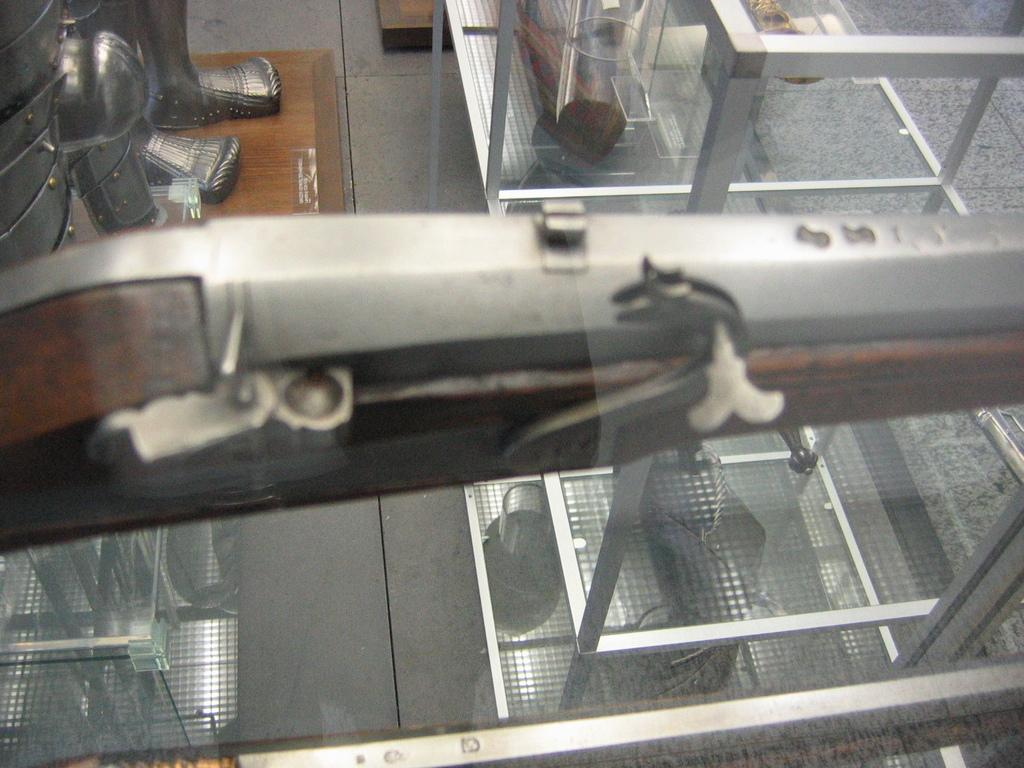What type of view is shown in the image? The image is an inside view. What can be seen on the floor in the image? There are metal objects on the floor in the image. What type of fiction is the person reading in the image? There is no person or book visible in the image, so it is not possible to determine if someone is reading fiction. 